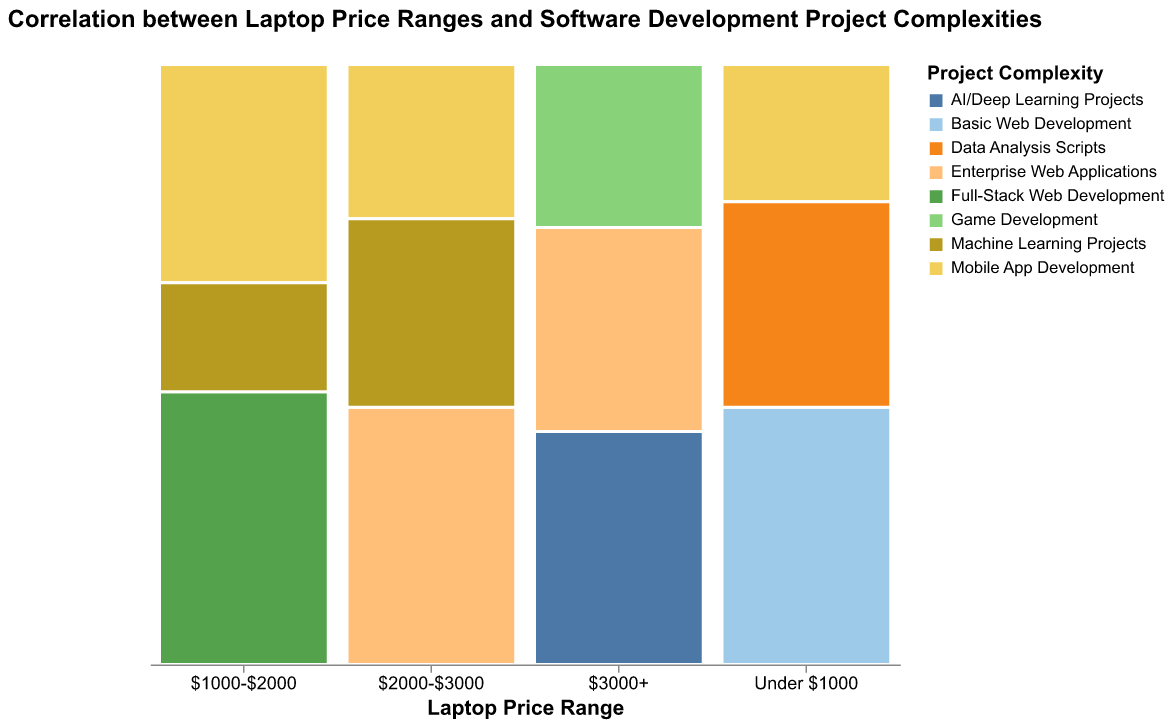What is the title of the chart? The title is usually provided at the top of the chart for context. In this case, it is stated in the visualization configuration.
Answer: Correlation between Laptop Price Ranges and Software Development Project Complexities How are the different project complexities represented in the chart? The project complexities are represented by different colors in the mosaic plot, as specified by the color encoding in the chart schema.
Answer: By different colors Which price range has the highest count for Game Development projects? By evaluating the segments corresponding to Game Development in each price range, we can locate the one with the largest section.
Answer: $3000+ How does the distribution of Mobile App Development projects vary across price ranges? To determine this, we compare the height of the sections representing Mobile App Development across different price ranges in the mosaic plot.
Answer: It decreases from the $1000-$2000 range to the $3000+ range What is the total count of Machine Learning Projects in the $2000-$3000 price range? By identifying the section for Machine Learning Projects in the $2000-$3000 price range and noting the count, we can determine the total count.
Answer: 22 Which price range has the highest overall count of projects, and what is that count? By assessing the total height of each price range column, we can identify which column is the tallest, indicating the highest count.
Answer: $3000+, 103 Compare the counts of Enterprise Web Applications and AI/Deep Learning Projects in the $3000+ price range. Which project type has a higher count? By examining the heights of the segments representing these project types within the $3000+ price range, we can determine the higher count.
Answer: AI/Deep Learning Projects What is the sum of counts for Full-Stack Web Development in the $1000-$2000 price range and Machine Learning Projects in the $2000-$3000 price range? We need to add the count of Full-Stack Web Development in the $1000-$2000 range (25) to the count of Machine Learning Projects in the $2000-$3000 range (22).
Answer: 47 Is there a notable increase or decrease in the count of AI/Deep Learning Projects with increasing price ranges? We track the AI/Deep Learning Projects count, which increases as we move from lower to higher price ranges, with a notably higher count in the $3000+ range.
Answer: Notable increase Which project complexity category within the Under $1000 price range has the smallest count, and what is that count? By looking at the segments within the Under $1000 price range, we identify the smallest section which represents Mobile App Development.
Answer: Mobile App Development, 8 